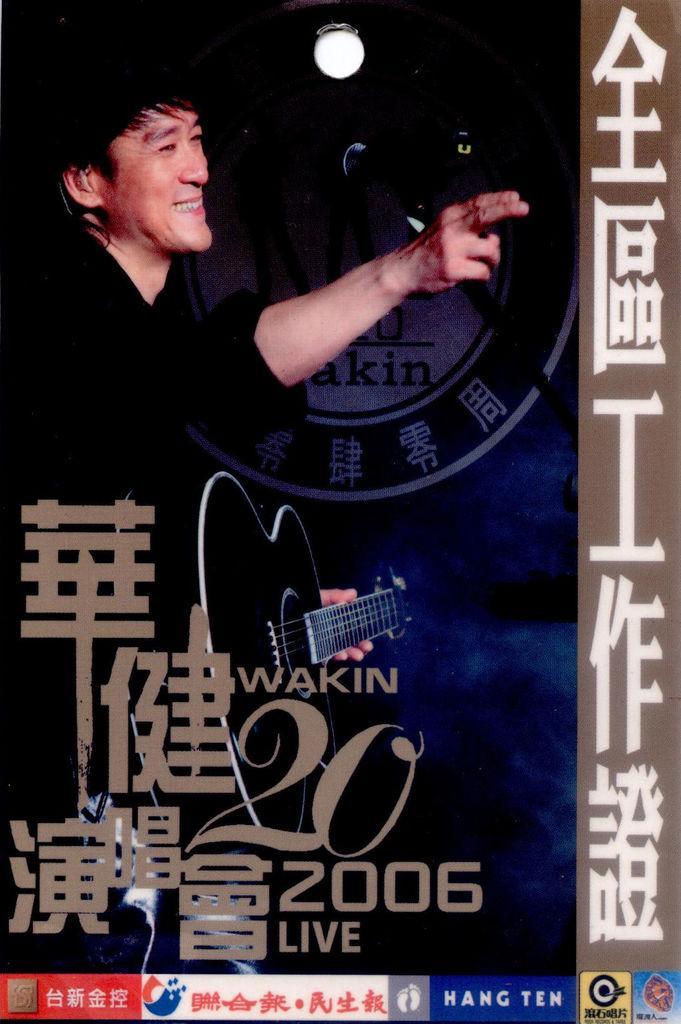What type of content is the image promoting? The image is an advertisement. What can be found in the image besides the visual content? There is text in the image. What is the person in the image doing? The person is holding a guitar in the image. Can you tell me how many times the beast uses the calculator in the image? There is no beast or calculator present in the image. 